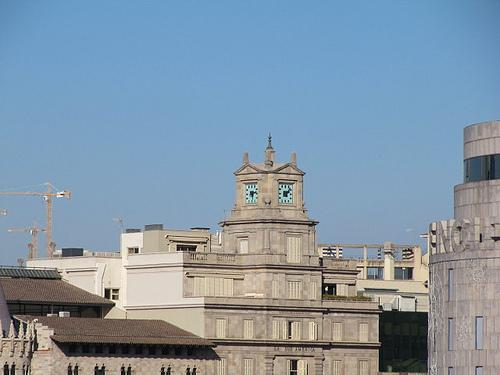Can you identify the primary objects present in the image and what they are related to? There are an old building with blue outside clocks, square windows, and a tower; a crane on the left side, and a sky in the background. What additional elements other than the building and the sky can be seen in the image?  A crane can be seen in the left side, and the building has letters made of brick. Count the total number of clocks mentioned in the image, and describe their location on the building. There are two outside blue clocks located on the top of the old tall building. Explain the appearance of the building and some of its details, like the color of roofs and window placement. The building is grey, with brown color roofs, and square windows attached to the tower walls at different positions. What is the dominant color of the sky in the image described? The dominant color of the sky is blue. Based on the information, can you determine what time of day the picture was taken? The picture was taken during day time. Describe the colors and details of the clocks on the building. The clocks on the building are blue and black, with two faces and outside in a square shape. Mention the characteristics of the windows that can be observed in the image. The windows are square-shaped and attached to the building wall, found at different positions on the tower. Describe the overall sentiment of the image. Is it positive, negative or neutral? The overall sentiment of the image is neutral. Analyze the interaction between the main objects in the image such as the building, tower, and crane. The crane is on the left side of the old tall building with a tower and blue clocks, possibly indicating construction or maintenance work being done. 